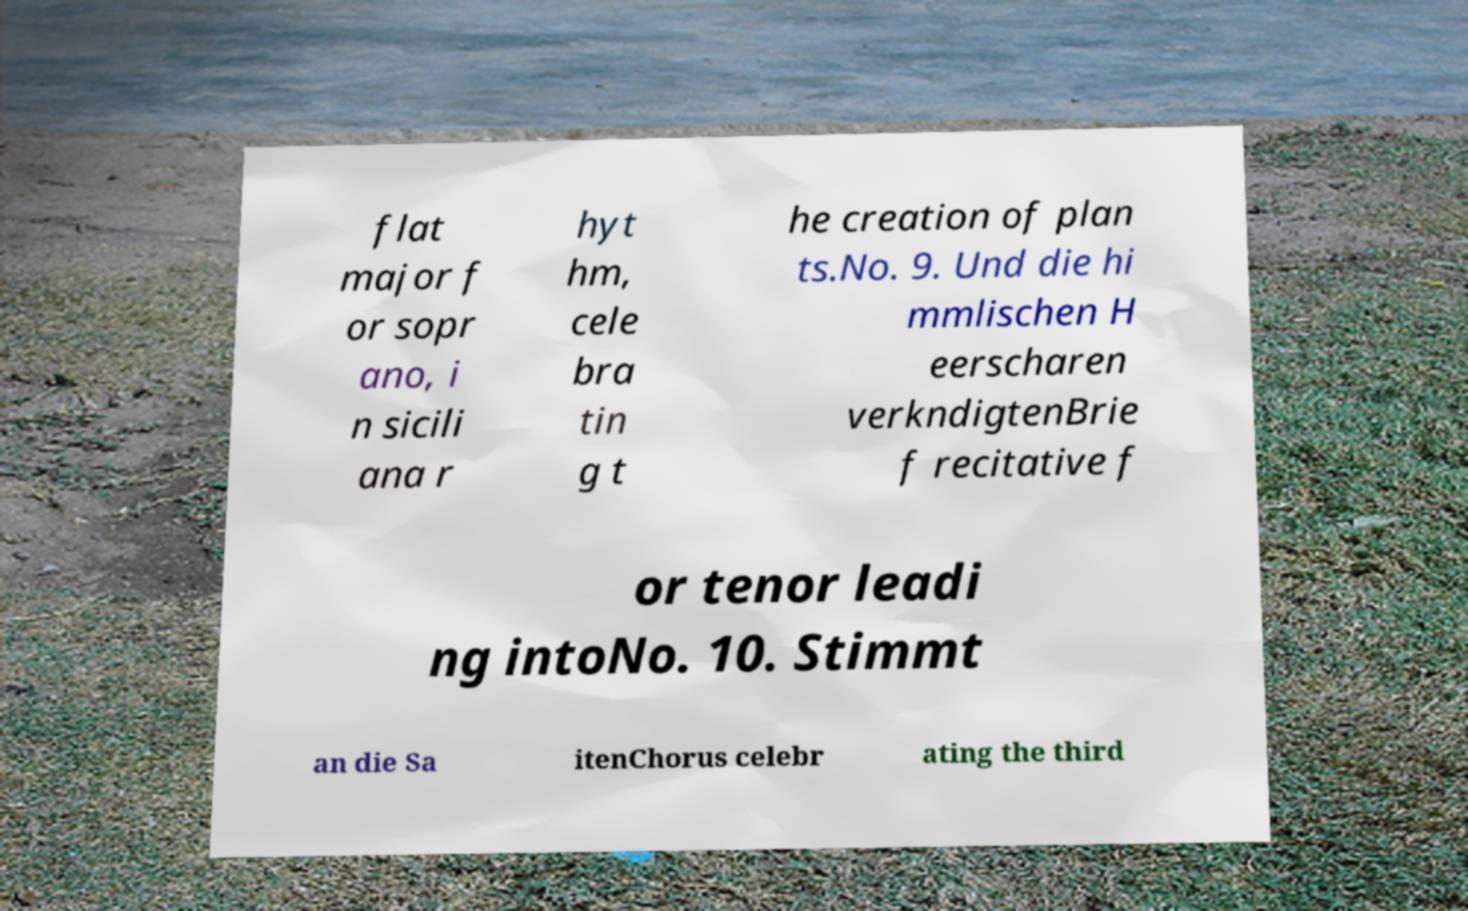Could you extract and type out the text from this image? flat major f or sopr ano, i n sicili ana r hyt hm, cele bra tin g t he creation of plan ts.No. 9. Und die hi mmlischen H eerscharen verkndigtenBrie f recitative f or tenor leadi ng intoNo. 10. Stimmt an die Sa itenChorus celebr ating the third 